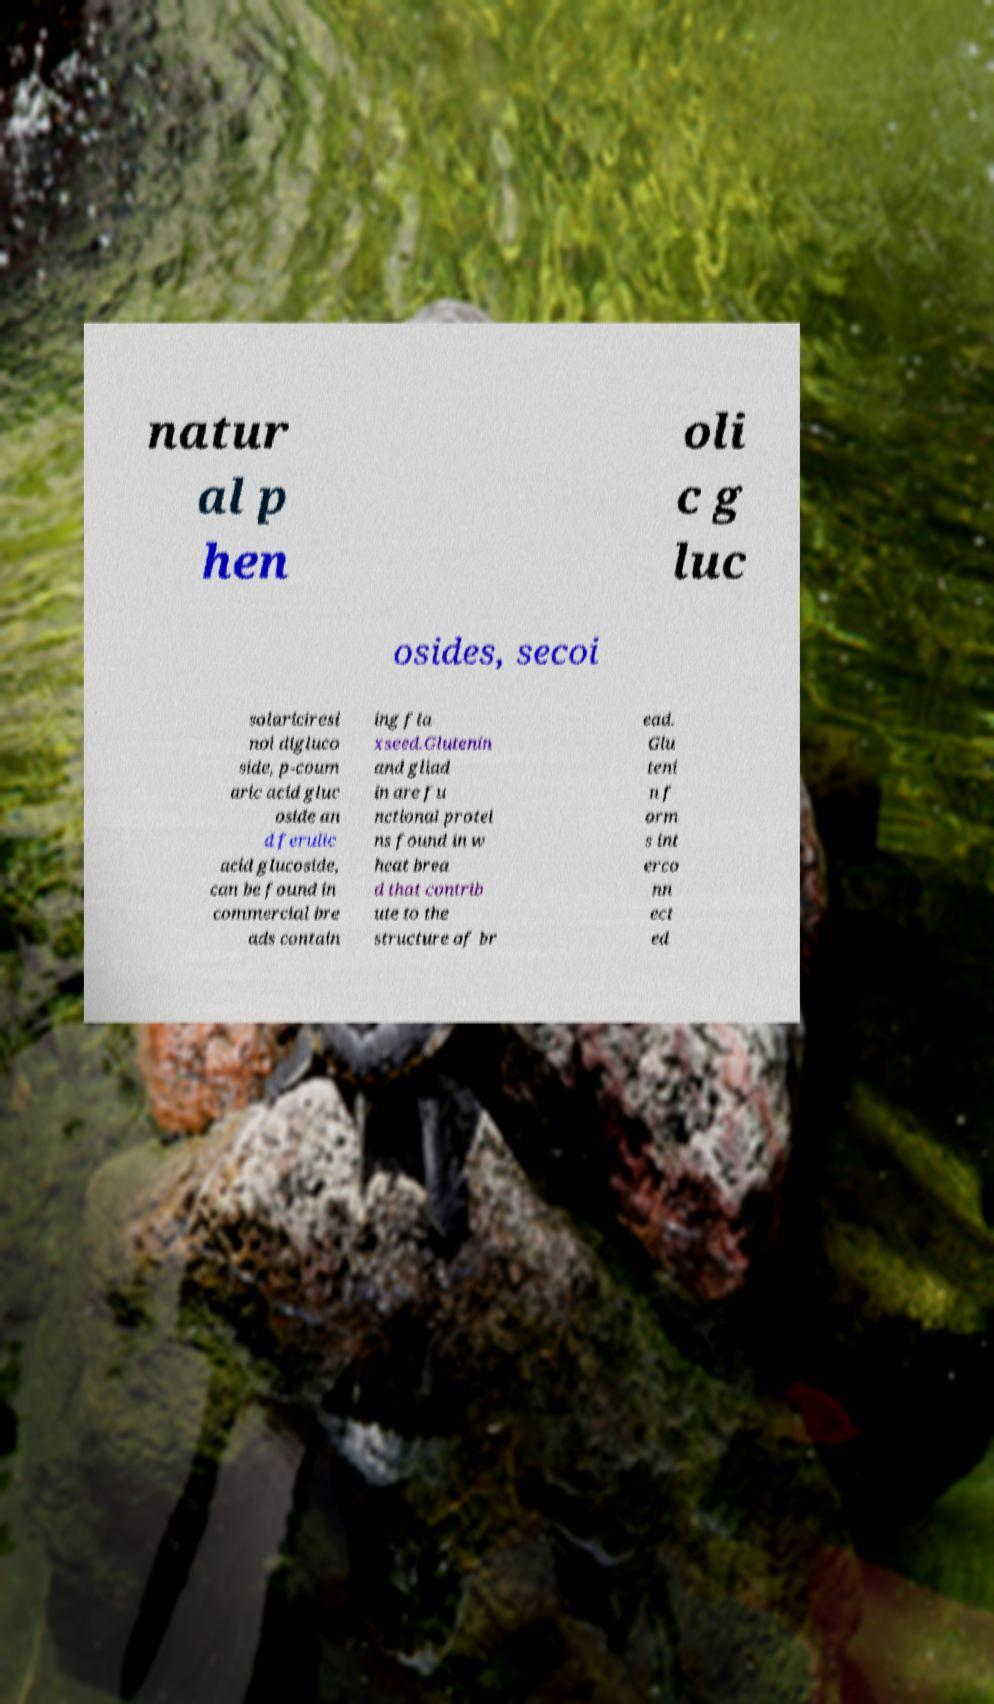There's text embedded in this image that I need extracted. Can you transcribe it verbatim? natur al p hen oli c g luc osides, secoi solariciresi nol digluco side, p-coum aric acid gluc oside an d ferulic acid glucoside, can be found in commercial bre ads contain ing fla xseed.Glutenin and gliad in are fu nctional protei ns found in w heat brea d that contrib ute to the structure of br ead. Glu teni n f orm s int erco nn ect ed 